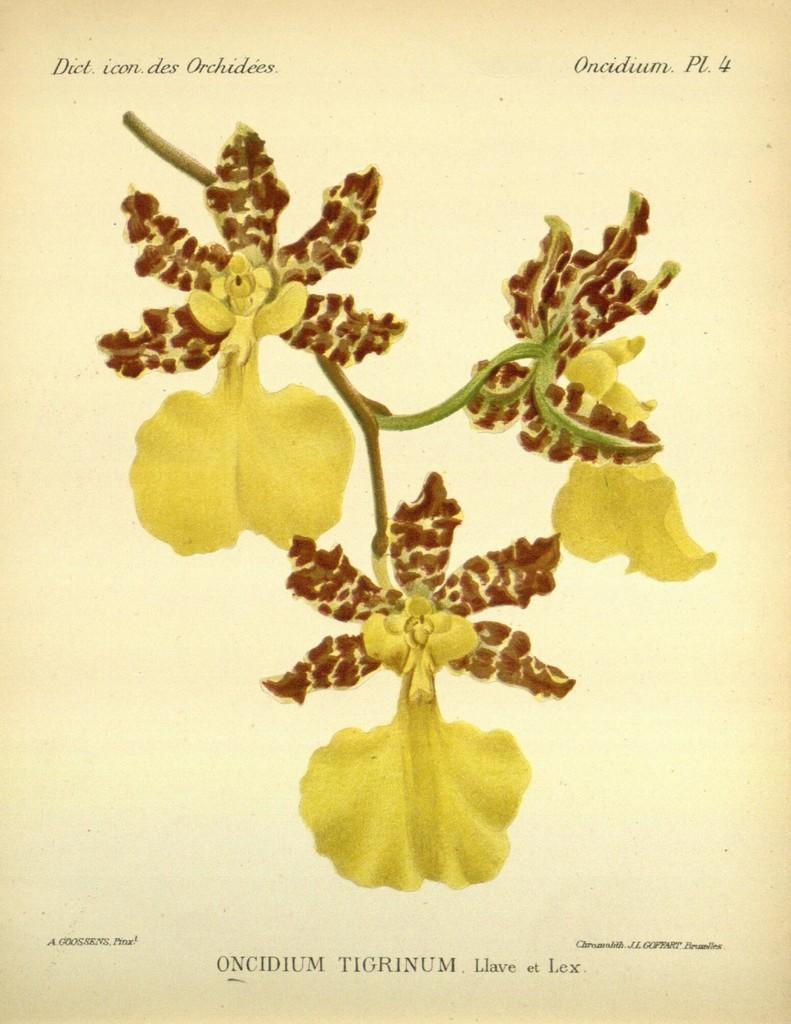<image>
Render a clear and concise summary of the photo. A drawing of a plant with the label Oncidium Tigrinum. 